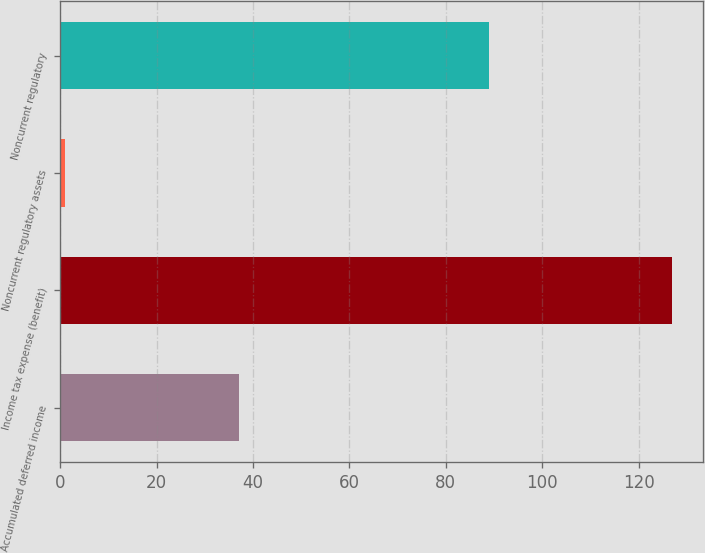Convert chart. <chart><loc_0><loc_0><loc_500><loc_500><bar_chart><fcel>Accumulated deferred income<fcel>Income tax expense (benefit)<fcel>Noncurrent regulatory assets<fcel>Noncurrent regulatory<nl><fcel>37<fcel>127<fcel>1<fcel>89<nl></chart> 